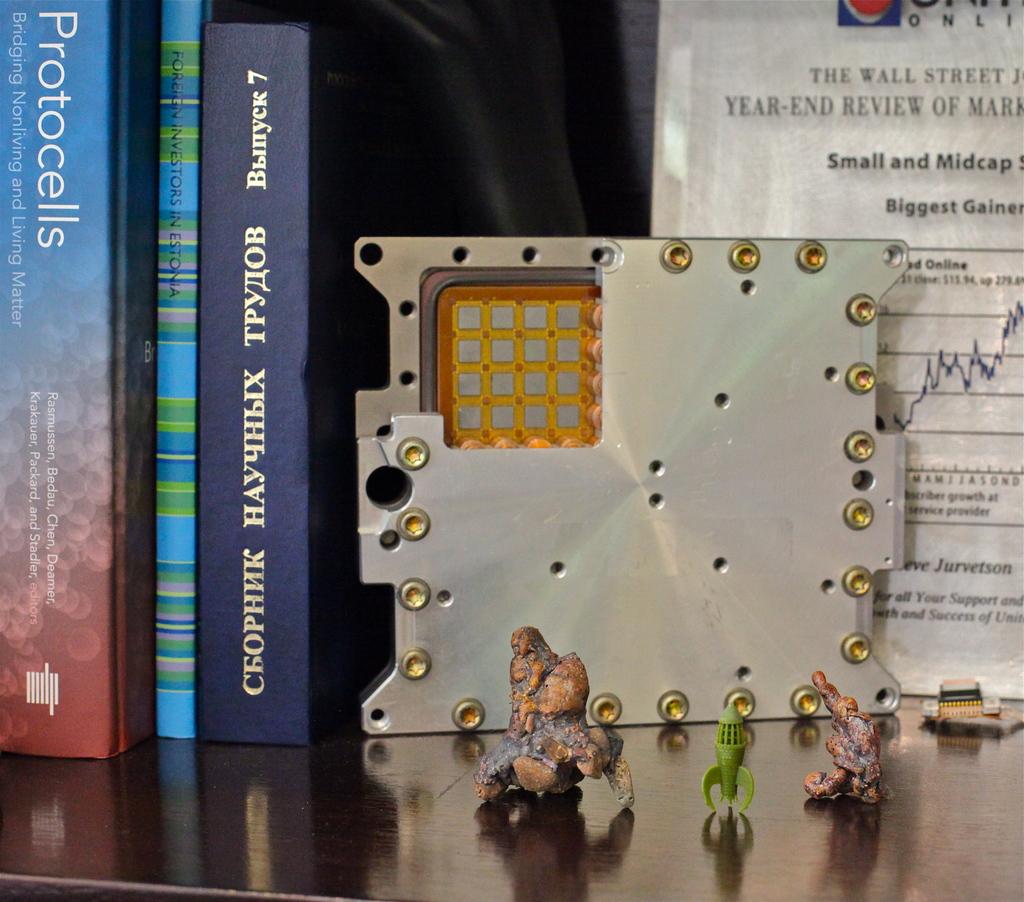What type of matter is the outside book about?
Your answer should be compact. Protocells. What type of review is showing on the paper?
Offer a terse response. Year-end. 